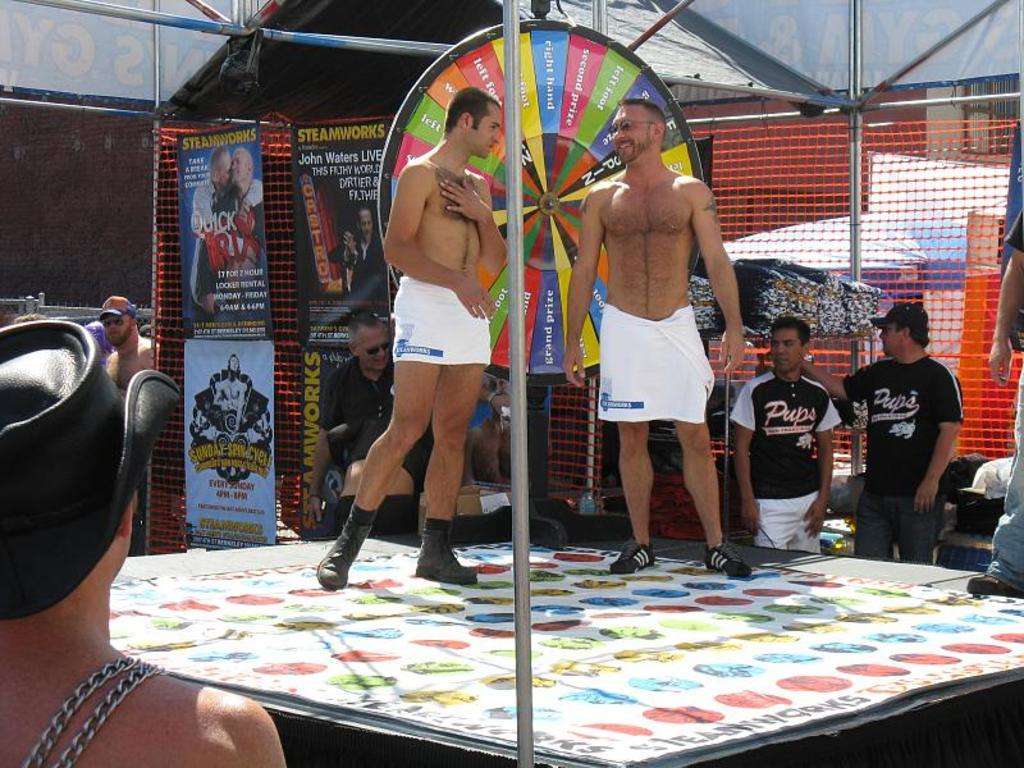<image>
Summarize the visual content of the image. Two men on a stage wearing white towels in front of Steamworks posters and men in Pups jerseys. 